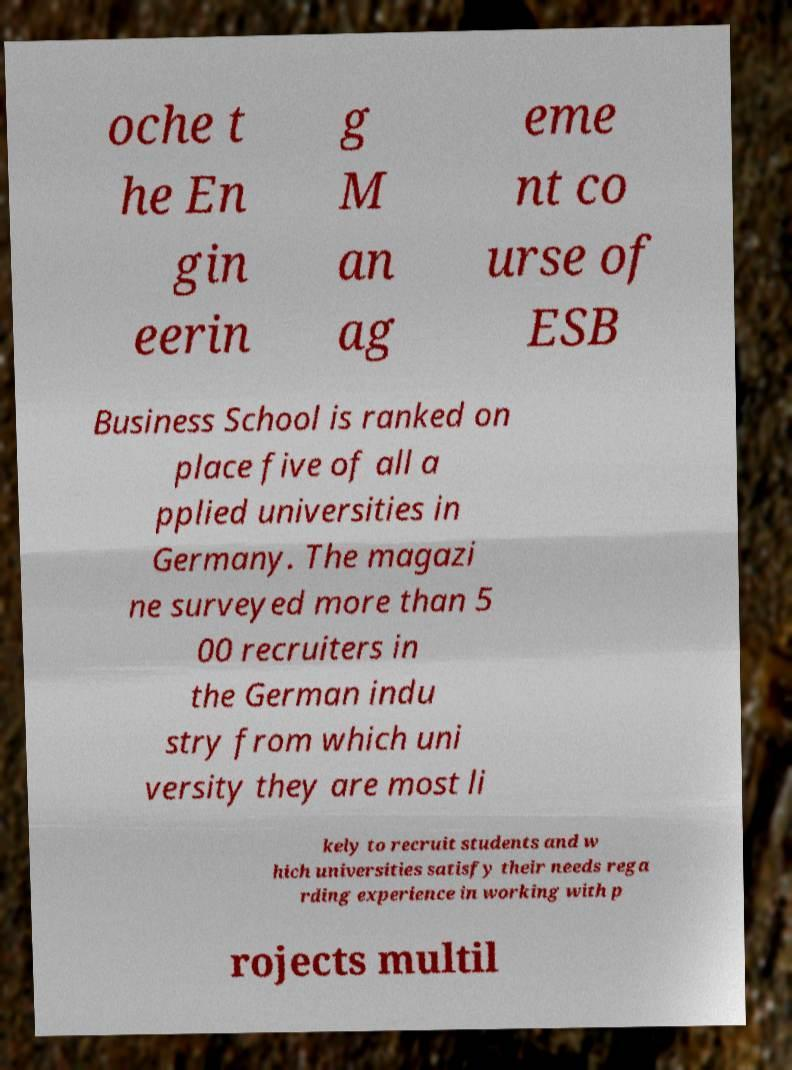Can you read and provide the text displayed in the image?This photo seems to have some interesting text. Can you extract and type it out for me? oche t he En gin eerin g M an ag eme nt co urse of ESB Business School is ranked on place five of all a pplied universities in Germany. The magazi ne surveyed more than 5 00 recruiters in the German indu stry from which uni versity they are most li kely to recruit students and w hich universities satisfy their needs rega rding experience in working with p rojects multil 